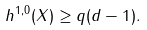<formula> <loc_0><loc_0><loc_500><loc_500>h ^ { 1 , 0 } ( X ) \geq q ( d - 1 ) .</formula> 